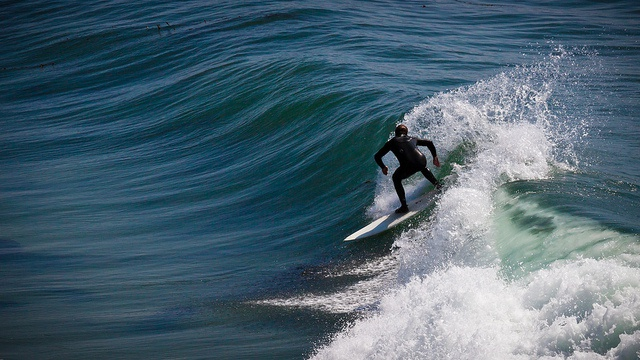Describe the objects in this image and their specific colors. I can see people in navy, black, gray, and darkgray tones and surfboard in navy, gray, blue, lightgray, and black tones in this image. 